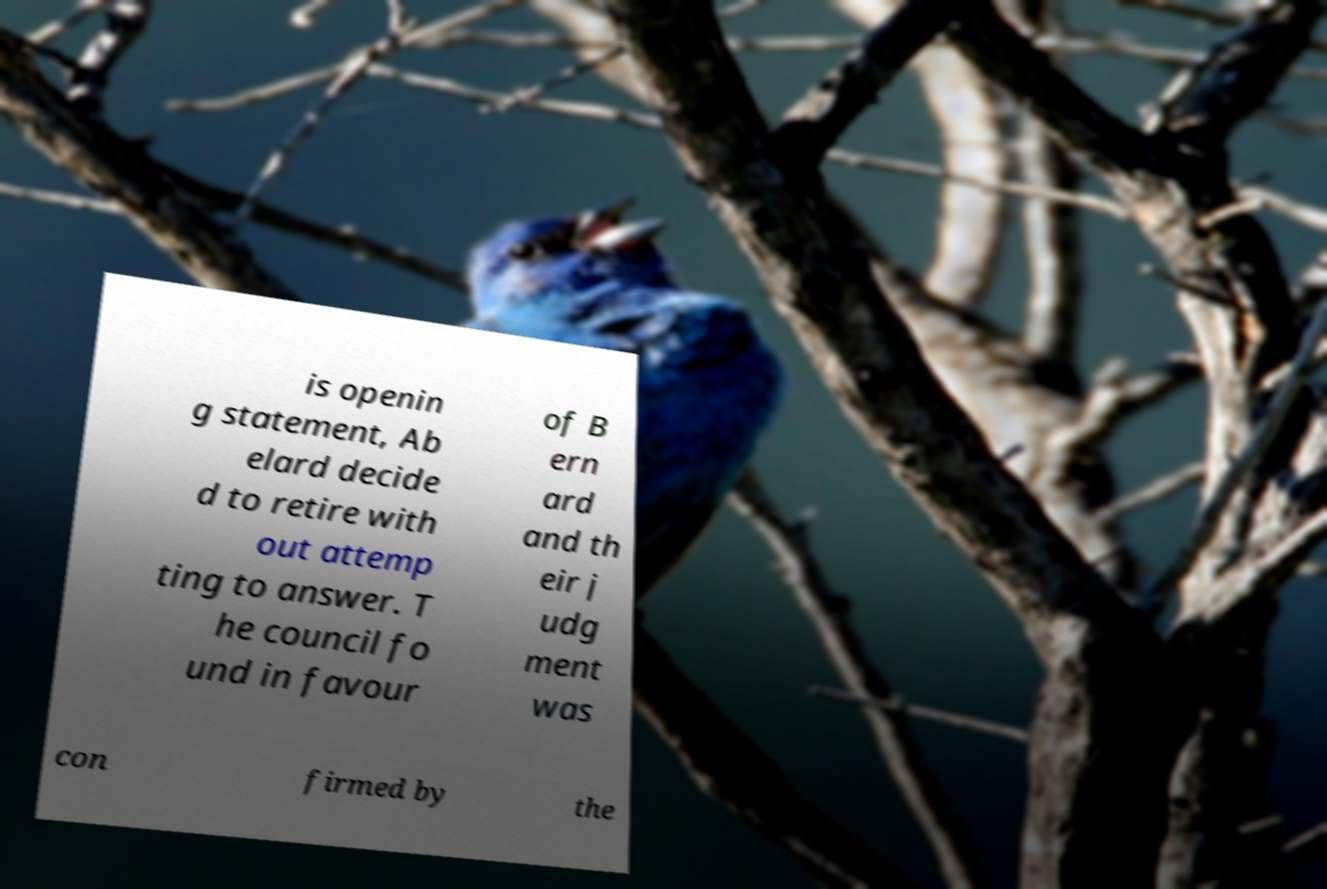Please read and relay the text visible in this image. What does it say? is openin g statement, Ab elard decide d to retire with out attemp ting to answer. T he council fo und in favour of B ern ard and th eir j udg ment was con firmed by the 